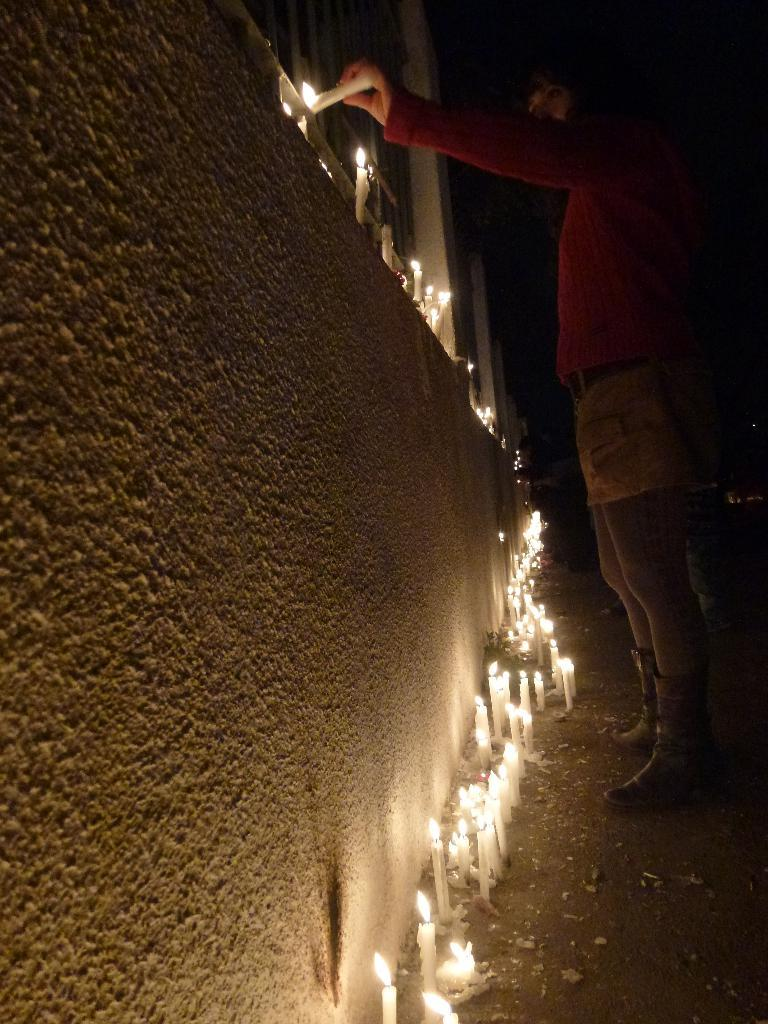What is the main subject of the image? There is a person standing in the image. Where is the person standing? The person is standing on the ground. What can be seen in the background of the image? The background of the image is dark. What objects are present in the image besides the person? There is a wall and candles in the image. What type of belief does the boy in the image have about the candles? There is no boy present in the image, and therefore no belief about the candles can be determined. 